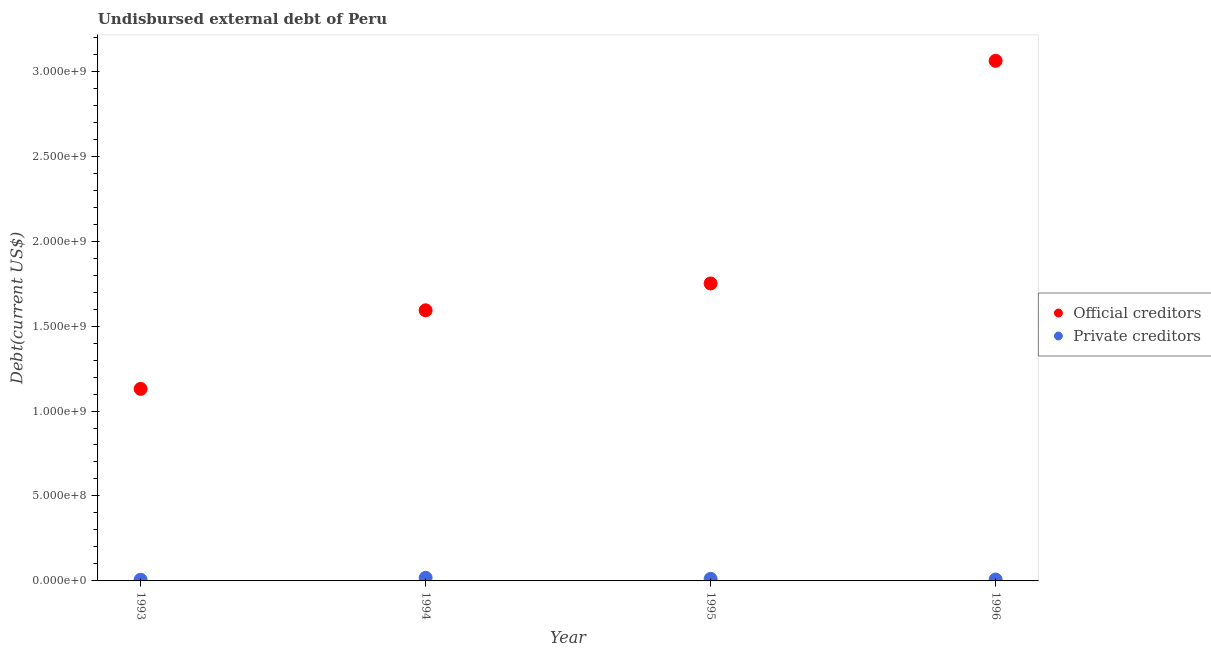How many different coloured dotlines are there?
Offer a terse response. 2. What is the undisbursed external debt of official creditors in 1995?
Offer a terse response. 1.75e+09. Across all years, what is the maximum undisbursed external debt of official creditors?
Your answer should be compact. 3.06e+09. Across all years, what is the minimum undisbursed external debt of official creditors?
Provide a succinct answer. 1.13e+09. In which year was the undisbursed external debt of official creditors minimum?
Keep it short and to the point. 1993. What is the total undisbursed external debt of private creditors in the graph?
Offer a terse response. 4.58e+07. What is the difference between the undisbursed external debt of official creditors in 1993 and that in 1996?
Offer a very short reply. -1.93e+09. What is the difference between the undisbursed external debt of private creditors in 1993 and the undisbursed external debt of official creditors in 1995?
Keep it short and to the point. -1.74e+09. What is the average undisbursed external debt of private creditors per year?
Make the answer very short. 1.14e+07. In the year 1995, what is the difference between the undisbursed external debt of official creditors and undisbursed external debt of private creditors?
Provide a succinct answer. 1.74e+09. What is the ratio of the undisbursed external debt of official creditors in 1995 to that in 1996?
Your response must be concise. 0.57. Is the undisbursed external debt of private creditors in 1995 less than that in 1996?
Ensure brevity in your answer.  No. Is the difference between the undisbursed external debt of official creditors in 1994 and 1996 greater than the difference between the undisbursed external debt of private creditors in 1994 and 1996?
Provide a succinct answer. No. What is the difference between the highest and the second highest undisbursed external debt of private creditors?
Keep it short and to the point. 6.18e+06. What is the difference between the highest and the lowest undisbursed external debt of private creditors?
Ensure brevity in your answer.  1.14e+07. In how many years, is the undisbursed external debt of official creditors greater than the average undisbursed external debt of official creditors taken over all years?
Provide a succinct answer. 1. Does the undisbursed external debt of official creditors monotonically increase over the years?
Offer a terse response. Yes. Is the undisbursed external debt of private creditors strictly greater than the undisbursed external debt of official creditors over the years?
Your answer should be compact. No. How many dotlines are there?
Make the answer very short. 2. How many years are there in the graph?
Your answer should be very brief. 4. Are the values on the major ticks of Y-axis written in scientific E-notation?
Ensure brevity in your answer.  Yes. How many legend labels are there?
Your response must be concise. 2. What is the title of the graph?
Ensure brevity in your answer.  Undisbursed external debt of Peru. Does "Exports of goods" appear as one of the legend labels in the graph?
Provide a short and direct response. No. What is the label or title of the Y-axis?
Your response must be concise. Debt(current US$). What is the Debt(current US$) of Official creditors in 1993?
Keep it short and to the point. 1.13e+09. What is the Debt(current US$) of Private creditors in 1993?
Provide a short and direct response. 6.98e+06. What is the Debt(current US$) of Official creditors in 1994?
Offer a terse response. 1.59e+09. What is the Debt(current US$) of Private creditors in 1994?
Provide a short and direct response. 1.84e+07. What is the Debt(current US$) in Official creditors in 1995?
Keep it short and to the point. 1.75e+09. What is the Debt(current US$) of Private creditors in 1995?
Your answer should be very brief. 1.22e+07. What is the Debt(current US$) in Official creditors in 1996?
Your answer should be very brief. 3.06e+09. What is the Debt(current US$) of Private creditors in 1996?
Your answer should be compact. 8.22e+06. Across all years, what is the maximum Debt(current US$) of Official creditors?
Make the answer very short. 3.06e+09. Across all years, what is the maximum Debt(current US$) of Private creditors?
Provide a short and direct response. 1.84e+07. Across all years, what is the minimum Debt(current US$) of Official creditors?
Ensure brevity in your answer.  1.13e+09. Across all years, what is the minimum Debt(current US$) in Private creditors?
Make the answer very short. 6.98e+06. What is the total Debt(current US$) of Official creditors in the graph?
Provide a short and direct response. 7.53e+09. What is the total Debt(current US$) in Private creditors in the graph?
Your response must be concise. 4.58e+07. What is the difference between the Debt(current US$) in Official creditors in 1993 and that in 1994?
Your answer should be compact. -4.63e+08. What is the difference between the Debt(current US$) of Private creditors in 1993 and that in 1994?
Ensure brevity in your answer.  -1.14e+07. What is the difference between the Debt(current US$) of Official creditors in 1993 and that in 1995?
Provide a short and direct response. -6.21e+08. What is the difference between the Debt(current US$) in Private creditors in 1993 and that in 1995?
Ensure brevity in your answer.  -5.21e+06. What is the difference between the Debt(current US$) of Official creditors in 1993 and that in 1996?
Give a very brief answer. -1.93e+09. What is the difference between the Debt(current US$) of Private creditors in 1993 and that in 1996?
Make the answer very short. -1.23e+06. What is the difference between the Debt(current US$) in Official creditors in 1994 and that in 1995?
Your answer should be very brief. -1.58e+08. What is the difference between the Debt(current US$) in Private creditors in 1994 and that in 1995?
Give a very brief answer. 6.18e+06. What is the difference between the Debt(current US$) in Official creditors in 1994 and that in 1996?
Provide a short and direct response. -1.47e+09. What is the difference between the Debt(current US$) of Private creditors in 1994 and that in 1996?
Ensure brevity in your answer.  1.02e+07. What is the difference between the Debt(current US$) of Official creditors in 1995 and that in 1996?
Offer a terse response. -1.31e+09. What is the difference between the Debt(current US$) in Private creditors in 1995 and that in 1996?
Provide a succinct answer. 3.98e+06. What is the difference between the Debt(current US$) of Official creditors in 1993 and the Debt(current US$) of Private creditors in 1994?
Provide a short and direct response. 1.11e+09. What is the difference between the Debt(current US$) in Official creditors in 1993 and the Debt(current US$) in Private creditors in 1995?
Make the answer very short. 1.12e+09. What is the difference between the Debt(current US$) of Official creditors in 1993 and the Debt(current US$) of Private creditors in 1996?
Provide a short and direct response. 1.12e+09. What is the difference between the Debt(current US$) of Official creditors in 1994 and the Debt(current US$) of Private creditors in 1995?
Offer a very short reply. 1.58e+09. What is the difference between the Debt(current US$) in Official creditors in 1994 and the Debt(current US$) in Private creditors in 1996?
Your answer should be compact. 1.58e+09. What is the difference between the Debt(current US$) in Official creditors in 1995 and the Debt(current US$) in Private creditors in 1996?
Give a very brief answer. 1.74e+09. What is the average Debt(current US$) in Official creditors per year?
Keep it short and to the point. 1.88e+09. What is the average Debt(current US$) of Private creditors per year?
Give a very brief answer. 1.14e+07. In the year 1993, what is the difference between the Debt(current US$) of Official creditors and Debt(current US$) of Private creditors?
Offer a terse response. 1.12e+09. In the year 1994, what is the difference between the Debt(current US$) of Official creditors and Debt(current US$) of Private creditors?
Provide a succinct answer. 1.57e+09. In the year 1995, what is the difference between the Debt(current US$) in Official creditors and Debt(current US$) in Private creditors?
Your answer should be very brief. 1.74e+09. In the year 1996, what is the difference between the Debt(current US$) of Official creditors and Debt(current US$) of Private creditors?
Make the answer very short. 3.05e+09. What is the ratio of the Debt(current US$) in Official creditors in 1993 to that in 1994?
Provide a succinct answer. 0.71. What is the ratio of the Debt(current US$) in Private creditors in 1993 to that in 1994?
Your response must be concise. 0.38. What is the ratio of the Debt(current US$) in Official creditors in 1993 to that in 1995?
Your response must be concise. 0.65. What is the ratio of the Debt(current US$) of Private creditors in 1993 to that in 1995?
Provide a succinct answer. 0.57. What is the ratio of the Debt(current US$) in Official creditors in 1993 to that in 1996?
Provide a succinct answer. 0.37. What is the ratio of the Debt(current US$) in Private creditors in 1993 to that in 1996?
Provide a short and direct response. 0.85. What is the ratio of the Debt(current US$) of Official creditors in 1994 to that in 1995?
Provide a short and direct response. 0.91. What is the ratio of the Debt(current US$) of Private creditors in 1994 to that in 1995?
Make the answer very short. 1.51. What is the ratio of the Debt(current US$) of Official creditors in 1994 to that in 1996?
Give a very brief answer. 0.52. What is the ratio of the Debt(current US$) of Private creditors in 1994 to that in 1996?
Give a very brief answer. 2.24. What is the ratio of the Debt(current US$) in Official creditors in 1995 to that in 1996?
Provide a short and direct response. 0.57. What is the ratio of the Debt(current US$) in Private creditors in 1995 to that in 1996?
Make the answer very short. 1.48. What is the difference between the highest and the second highest Debt(current US$) in Official creditors?
Give a very brief answer. 1.31e+09. What is the difference between the highest and the second highest Debt(current US$) of Private creditors?
Your answer should be compact. 6.18e+06. What is the difference between the highest and the lowest Debt(current US$) in Official creditors?
Make the answer very short. 1.93e+09. What is the difference between the highest and the lowest Debt(current US$) of Private creditors?
Give a very brief answer. 1.14e+07. 